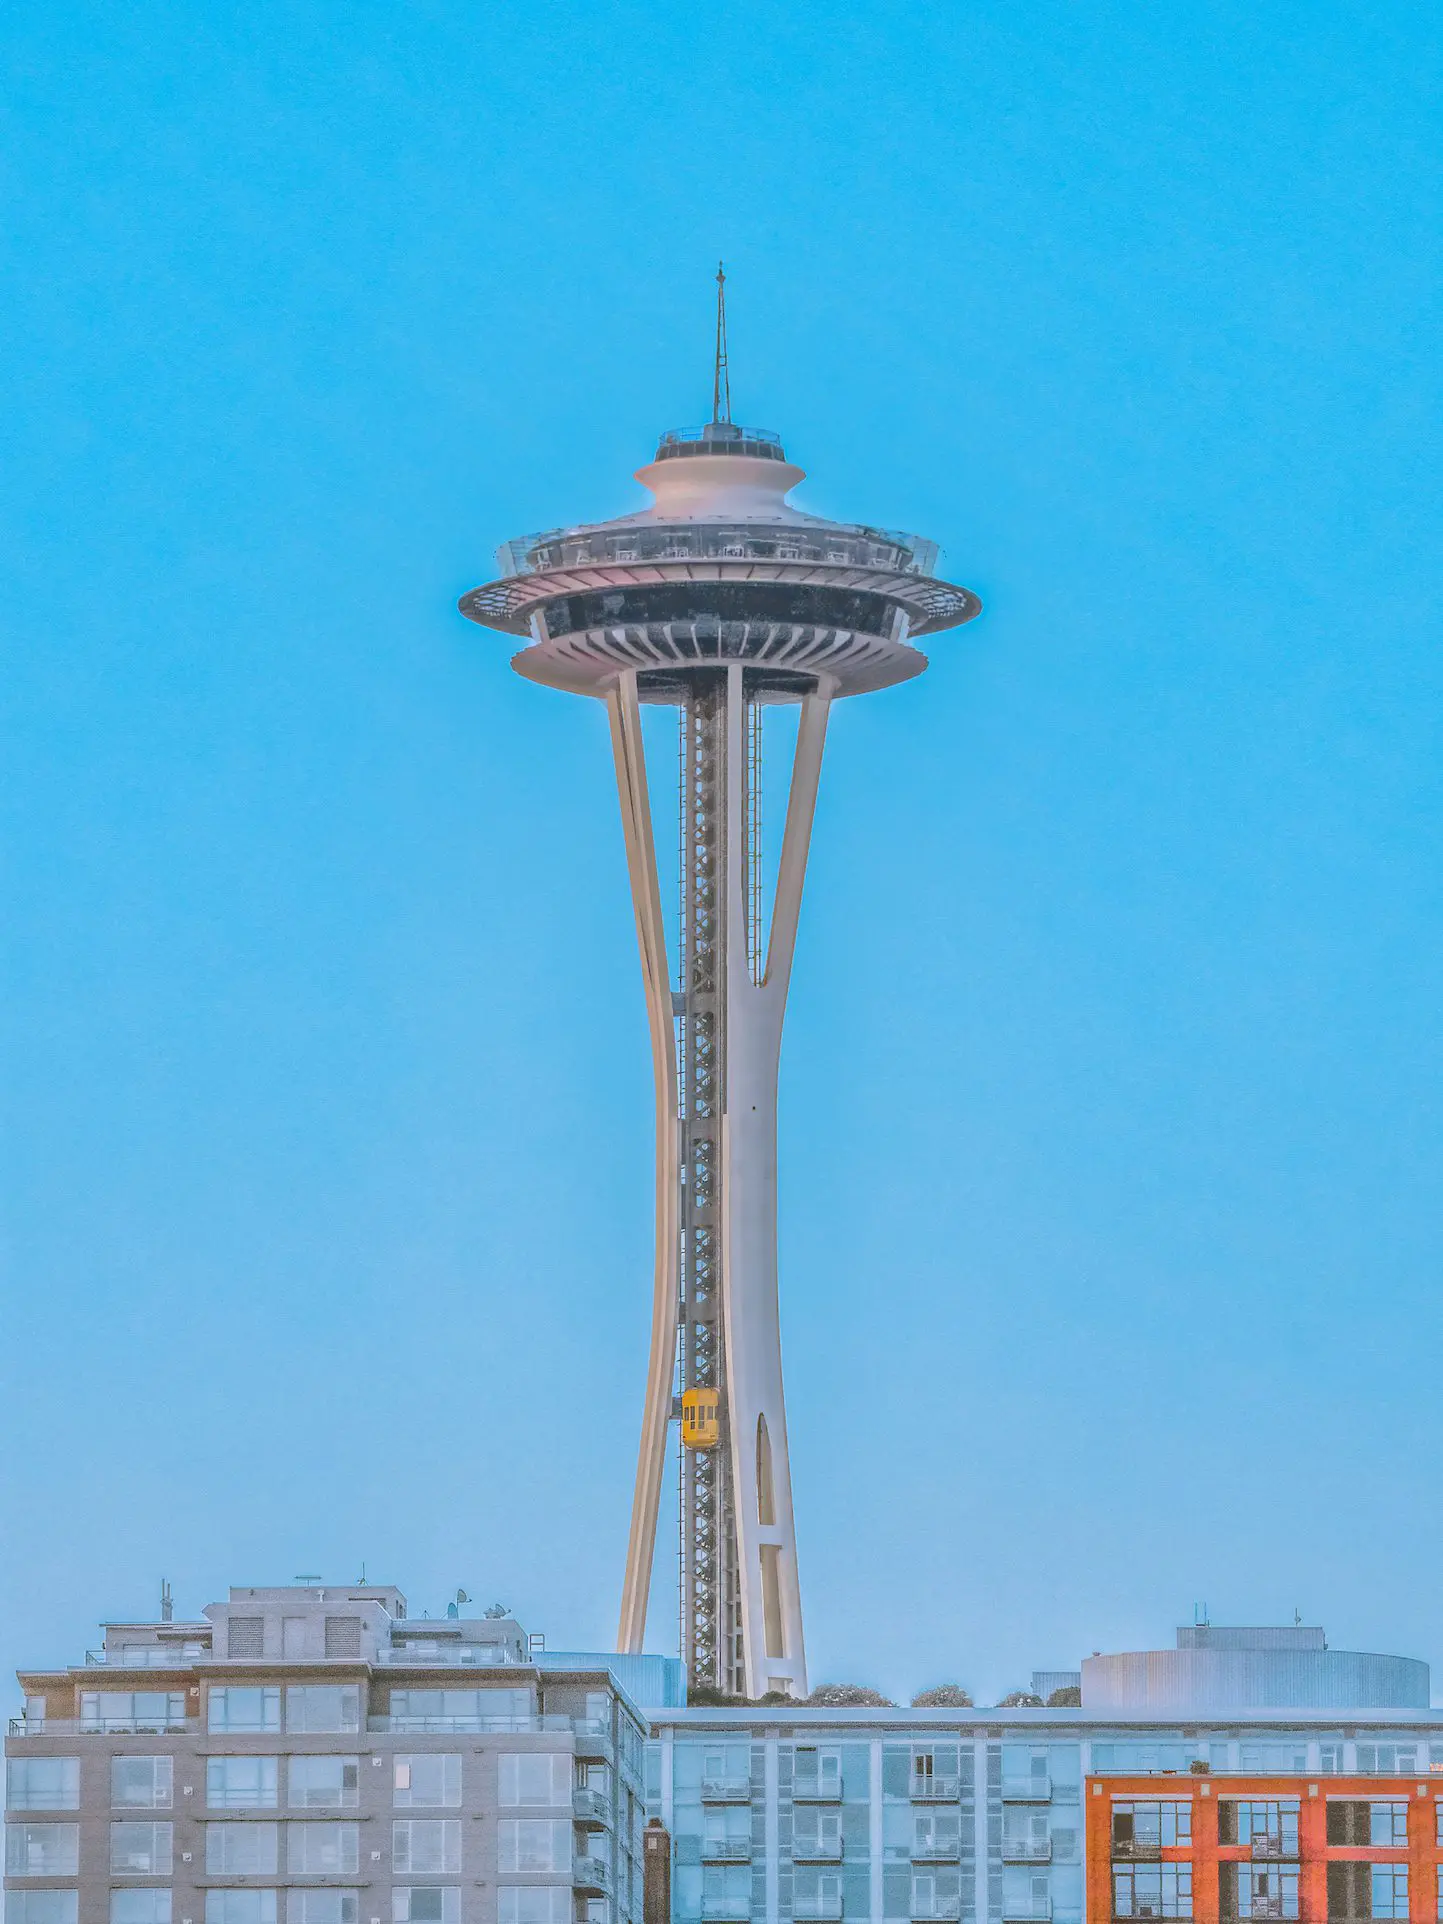What's happening in the scene? The image prominently features the celebrated Space Needle in Seattle, Washington. Standing out against a serene blue sky, this architectural marvel with its intricate design and towering spire takes center stage. The observation deck near its peak promises breathtaking panoramic views for visitors. Below, the cityscape is evident, showcasing a variety of nearby buildings. The perspective gives a dramatic, upward look, emphasizing the grandeur and stature of the Space Needle. 